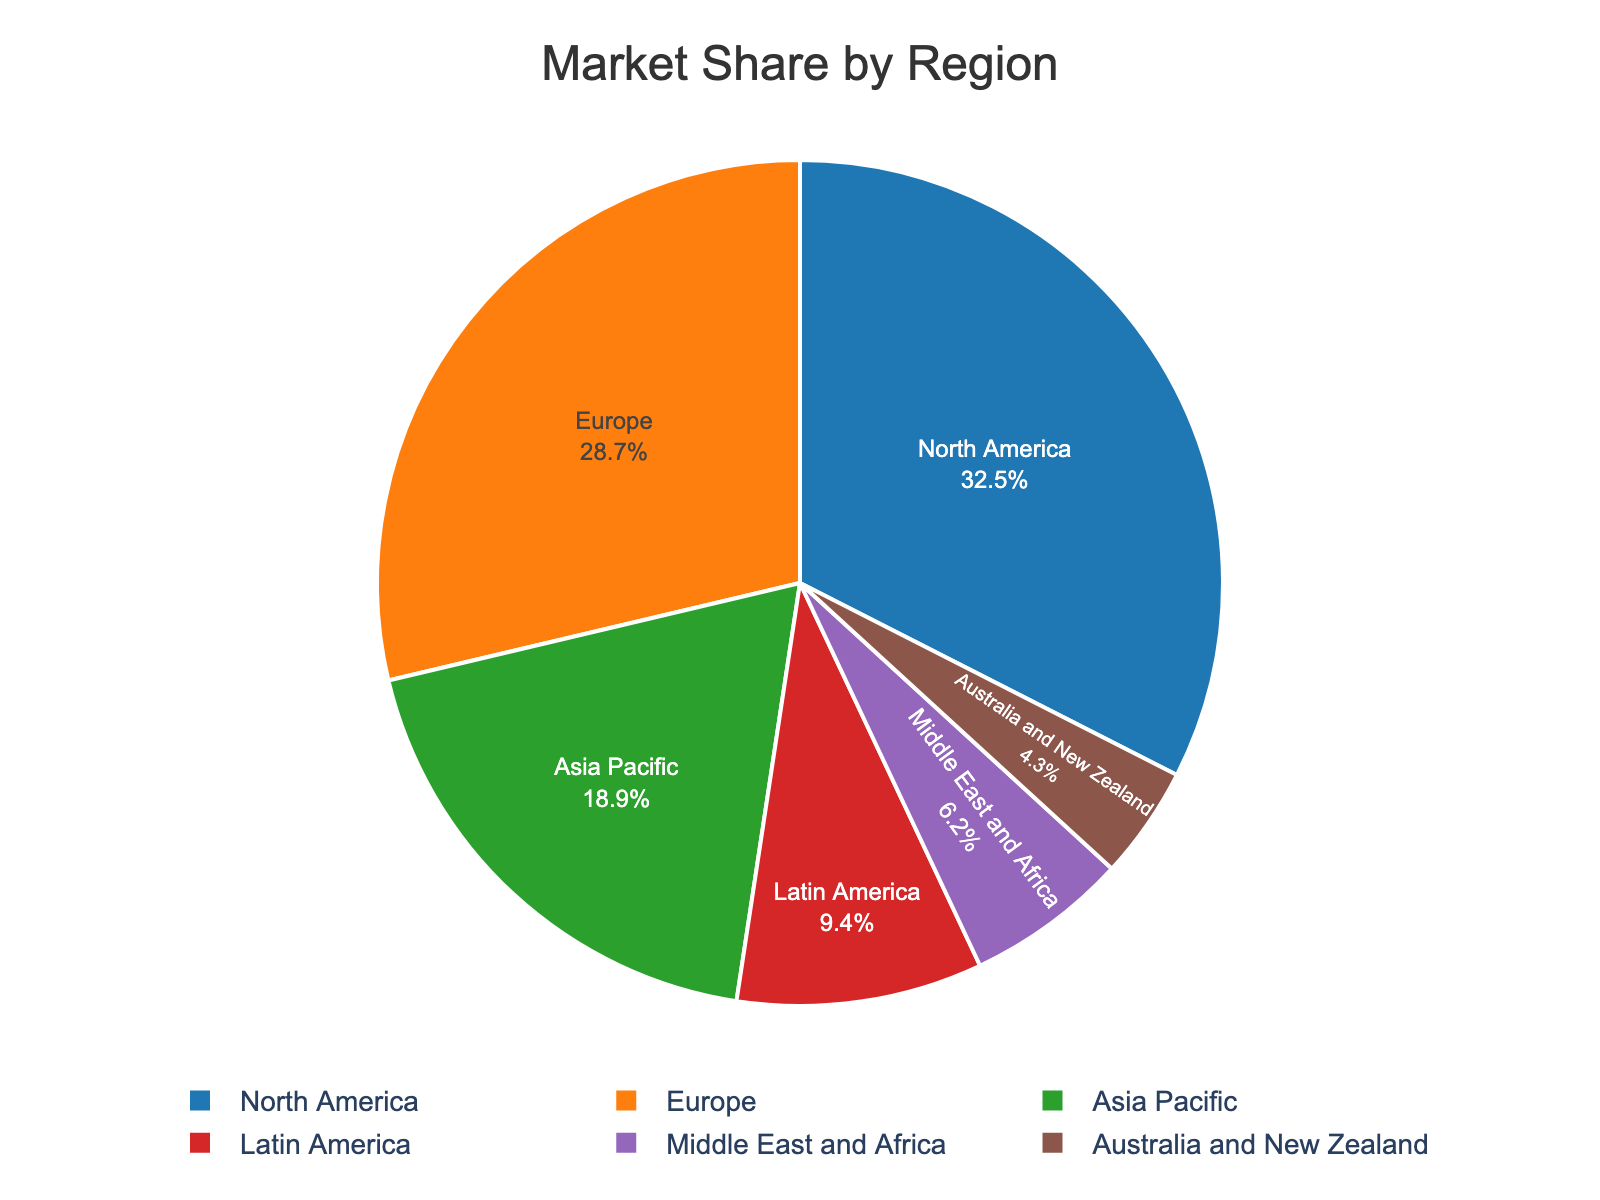what is the market share of North America? To find North America's market share, look for the segment labeled "North America" on the pie chart. The label will show the percentage directly.
Answer: 32.5% Which region has the smallest market share? Look for the segment with the smallest size and check the label to identify the region.
Answer: Australia and New Zealand What is the combined market share of Europe and Asia Pacific? Locate the segments for Europe and Asia Pacific. Add their percentages together: 28.7% (Europe) + 18.9% (Asia Pacific) = 47.6%
Answer: 47.6% How does the market share of the Middle East and Africa compare to that of Latin America? Compare the percentages of the segments labeled "Middle East and Africa" and "Latin America." Middle East and Africa is 6.2%, and Latin America is 9.4%. 6.2% is less than 9.4%.
Answer: less Which are the two regions with the closest market shares? Examine the segments and find the pair of regions with the smallest difference in percentages. Australia and New Zealand (4.3%) and the Middle East and Africa (6.2%) have a difference of 1.9%.
Answer: Australia and New Zealand and Middle East and Africa What is the difference in market share between North America and Europe? Find the percentages of North America (32.5%) and Europe (28.7%). Subtract the smaller percentage from the larger one: 32.5% - 28.7% = 3.8%
Answer: 3.8% How many regions have a market share greater than 10%? Check each segment to see the percentage and count the ones with values over 10%. There are three: North America (32.5%), Europe (28.7%), and Asia Pacific (18.9%).
Answer: 3 What’s the average market share of Latin America, the Middle East and Africa, and Australia and New Zealand? Add the percentages and divide by 3: (9.4% + 6.2% + 4.3%) / 3 = 19.9% / 3 = 6.63%
Answer: 6.63% Which segment has a light green color? Identify the visual appearance of the segments and find the one with the light green color, which is associated with Asia Pacific.
Answer: Asia Pacific 